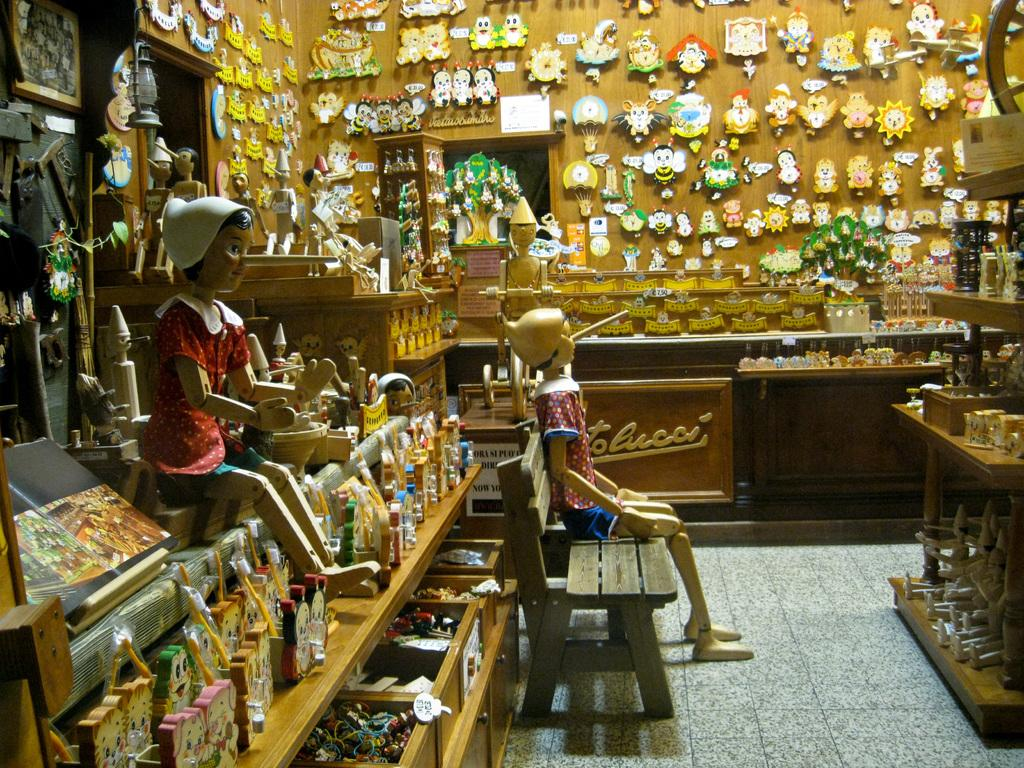What type of objects can be seen in the image? There are dolls in the image. Can you describe the position of one of the dolls? One doll is sitting on a bench. Where is the bench located in the image? The bench is present in the middle of the image. What might the setting of the image be? The image appears to depict a toy shop. How many ladybugs are crawling on the dolls in the image? There are no ladybugs present in the image; it only features dolls and a bench. 